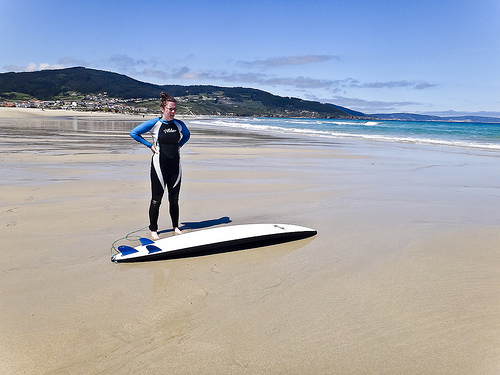Please provide a short description for this region: [0.07, 0.23, 0.23, 0.3]. This portion of the image reveals a majestic range of mountains in the distance, their peaks possibly covered with a hint of snow, creating a dramatic and beautiful natural skyline. 